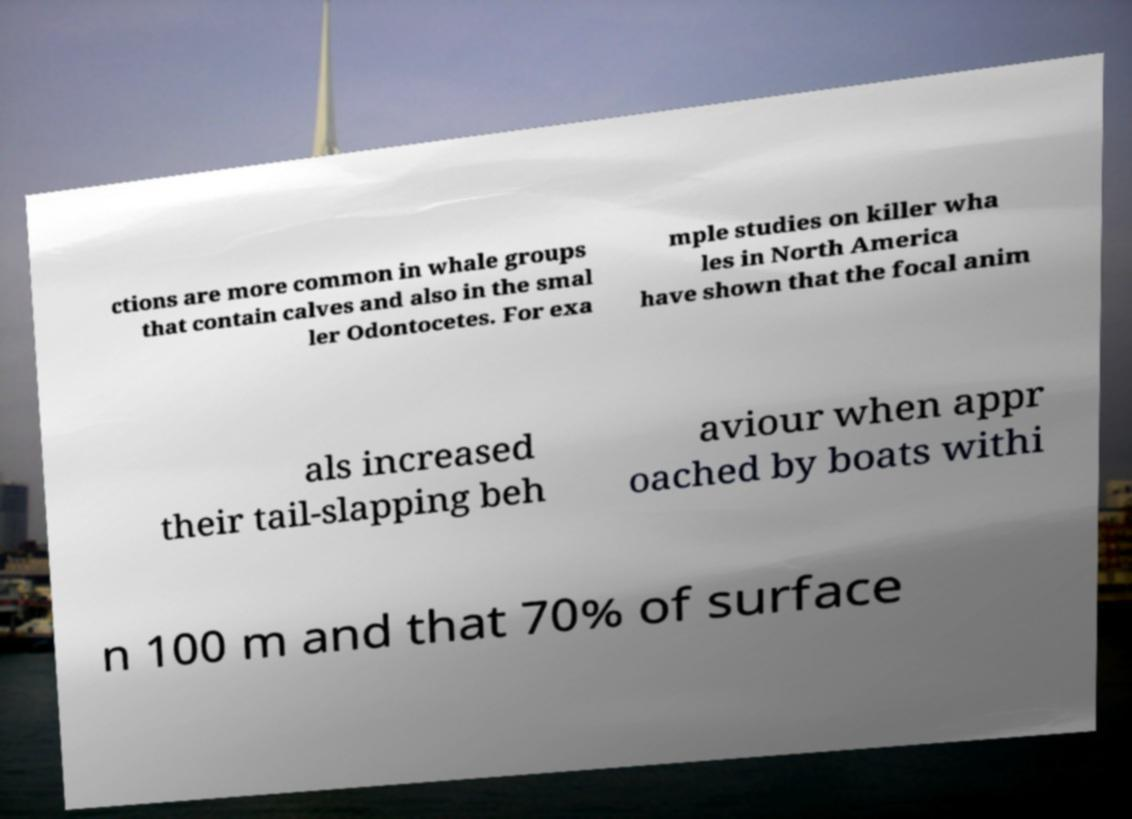Could you assist in decoding the text presented in this image and type it out clearly? ctions are more common in whale groups that contain calves and also in the smal ler Odontocetes. For exa mple studies on killer wha les in North America have shown that the focal anim als increased their tail-slapping beh aviour when appr oached by boats withi n 100 m and that 70% of surface 